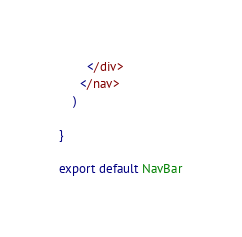<code> <loc_0><loc_0><loc_500><loc_500><_JavaScript_>        </div>
      </nav>
    )

}

export default NavBar</code> 